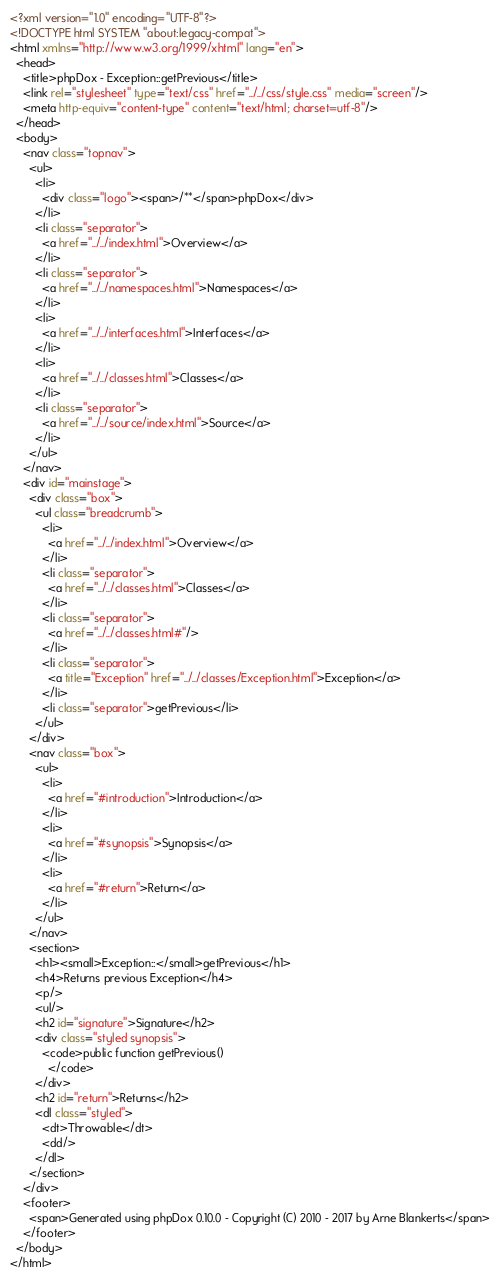Convert code to text. <code><loc_0><loc_0><loc_500><loc_500><_HTML_><?xml version="1.0" encoding="UTF-8"?>
<!DOCTYPE html SYSTEM "about:legacy-compat">
<html xmlns="http://www.w3.org/1999/xhtml" lang="en">
  <head>
    <title>phpDox - Exception::getPrevious</title>
    <link rel="stylesheet" type="text/css" href="../../css/style.css" media="screen"/>
    <meta http-equiv="content-type" content="text/html; charset=utf-8"/>
  </head>
  <body>
    <nav class="topnav">
      <ul>
        <li>
          <div class="logo"><span>/**</span>phpDox</div>
        </li>
        <li class="separator">
          <a href="../../index.html">Overview</a>
        </li>
        <li class="separator">
          <a href="../../namespaces.html">Namespaces</a>
        </li>
        <li>
          <a href="../../interfaces.html">Interfaces</a>
        </li>
        <li>
          <a href="../../classes.html">Classes</a>
        </li>
        <li class="separator">
          <a href="../../source/index.html">Source</a>
        </li>
      </ul>
    </nav>
    <div id="mainstage">
      <div class="box">
        <ul class="breadcrumb">
          <li>
            <a href="../../index.html">Overview</a>
          </li>
          <li class="separator">
            <a href="../../classes.html">Classes</a>
          </li>
          <li class="separator">
            <a href="../../classes.html#"/>
          </li>
          <li class="separator">
            <a title="Exception" href="../../classes/Exception.html">Exception</a>
          </li>
          <li class="separator">getPrevious</li>
        </ul>
      </div>
      <nav class="box">
        <ul>
          <li>
            <a href="#introduction">Introduction</a>
          </li>
          <li>
            <a href="#synopsis">Synopsis</a>
          </li>
          <li>
            <a href="#return">Return</a>
          </li>
        </ul>
      </nav>
      <section>
        <h1><small>Exception::</small>getPrevious</h1>
        <h4>Returns previous Exception</h4>
        <p/>
        <ul/>
        <h2 id="signature">Signature</h2>
        <div class="styled synopsis">
          <code>public function getPrevious()
            </code>
        </div>
        <h2 id="return">Returns</h2>
        <dl class="styled">
          <dt>Throwable</dt>
          <dd/>
        </dl>
      </section>
    </div>
    <footer>
      <span>Generated using phpDox 0.10.0 - Copyright (C) 2010 - 2017 by Arne Blankerts</span>
    </footer>
  </body>
</html>
</code> 